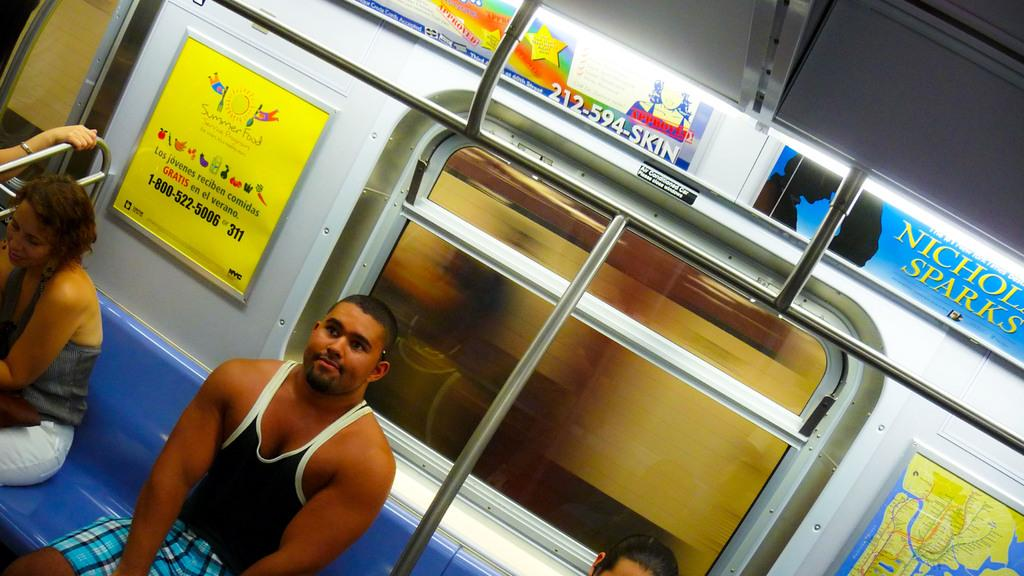<image>
Create a compact narrative representing the image presented. A man sits on a subway train beneath an advertisement for a Nicholas Sparks book. 